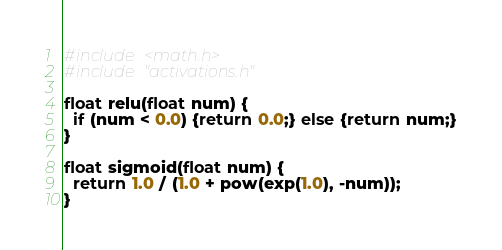Convert code to text. <code><loc_0><loc_0><loc_500><loc_500><_C_>#include <math.h>
#include "activations.h"

float relu(float num) {
  if (num < 0.0) {return 0.0;} else {return num;}
}

float sigmoid(float num) {
  return 1.0 / (1.0 + pow(exp(1.0), -num)); 
}</code> 